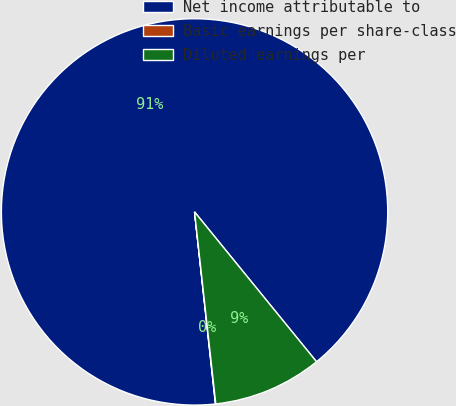Convert chart to OTSL. <chart><loc_0><loc_0><loc_500><loc_500><pie_chart><fcel>Net income attributable to<fcel>Basic earnings per share-class<fcel>Diluted earnings per<nl><fcel>90.85%<fcel>0.03%<fcel>9.12%<nl></chart> 